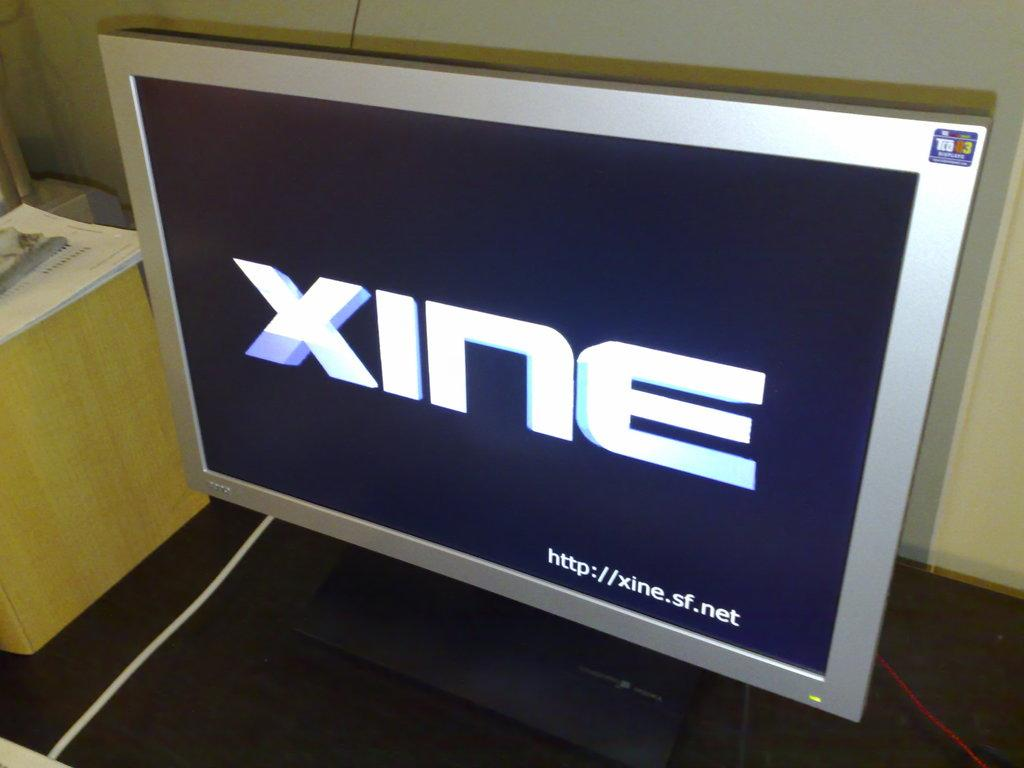<image>
Present a compact description of the photo's key features. A silver-framed TV screen displays the word xine. 